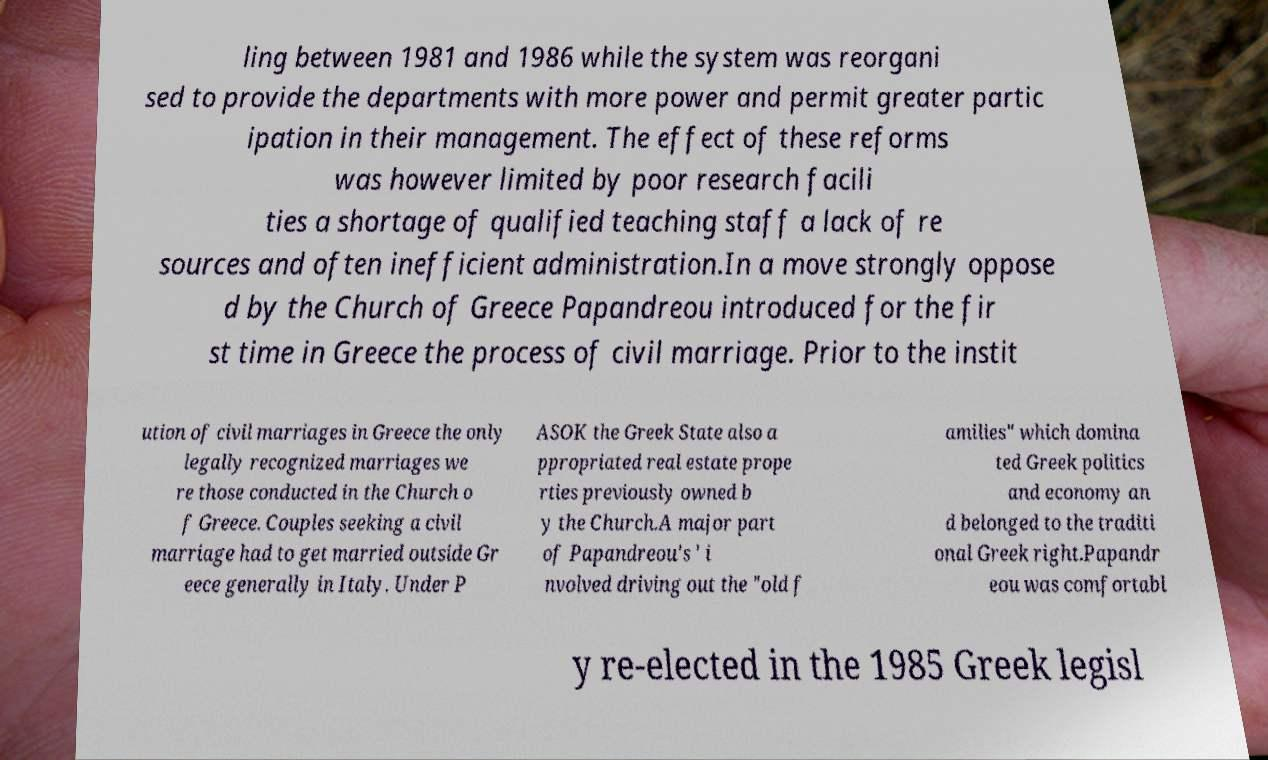I need the written content from this picture converted into text. Can you do that? ling between 1981 and 1986 while the system was reorgani sed to provide the departments with more power and permit greater partic ipation in their management. The effect of these reforms was however limited by poor research facili ties a shortage of qualified teaching staff a lack of re sources and often inefficient administration.In a move strongly oppose d by the Church of Greece Papandreou introduced for the fir st time in Greece the process of civil marriage. Prior to the instit ution of civil marriages in Greece the only legally recognized marriages we re those conducted in the Church o f Greece. Couples seeking a civil marriage had to get married outside Gr eece generally in Italy. Under P ASOK the Greek State also a ppropriated real estate prope rties previously owned b y the Church.A major part of Papandreou's ' i nvolved driving out the "old f amilies" which domina ted Greek politics and economy an d belonged to the traditi onal Greek right.Papandr eou was comfortabl y re-elected in the 1985 Greek legisl 